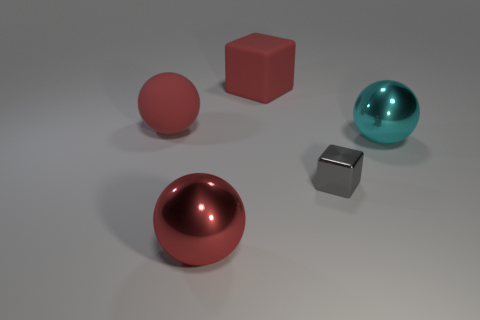Add 4 red matte blocks. How many red matte blocks exist? 5 Add 5 small shiny objects. How many objects exist? 10 Subtract all cyan spheres. How many spheres are left? 2 Subtract all large metal spheres. How many spheres are left? 1 Subtract 0 purple cylinders. How many objects are left? 5 Subtract all blocks. How many objects are left? 3 Subtract 1 blocks. How many blocks are left? 1 Subtract all green spheres. Subtract all cyan blocks. How many spheres are left? 3 Subtract all gray spheres. How many purple blocks are left? 0 Subtract all rubber objects. Subtract all blocks. How many objects are left? 1 